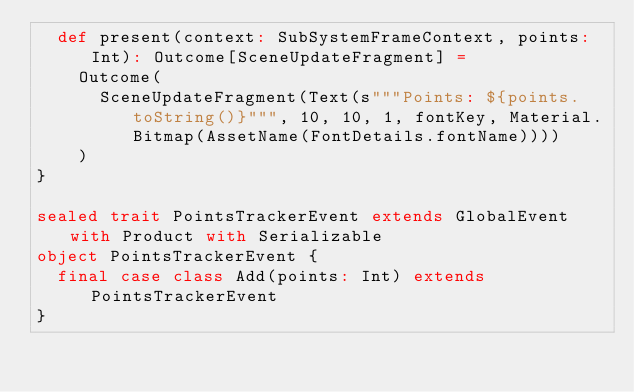<code> <loc_0><loc_0><loc_500><loc_500><_Scala_>  def present(context: SubSystemFrameContext, points: Int): Outcome[SceneUpdateFragment] =
    Outcome(
      SceneUpdateFragment(Text(s"""Points: ${points.toString()}""", 10, 10, 1, fontKey, Material.Bitmap(AssetName(FontDetails.fontName))))
    )
}

sealed trait PointsTrackerEvent extends GlobalEvent with Product with Serializable
object PointsTrackerEvent {
  final case class Add(points: Int) extends PointsTrackerEvent
}
</code> 